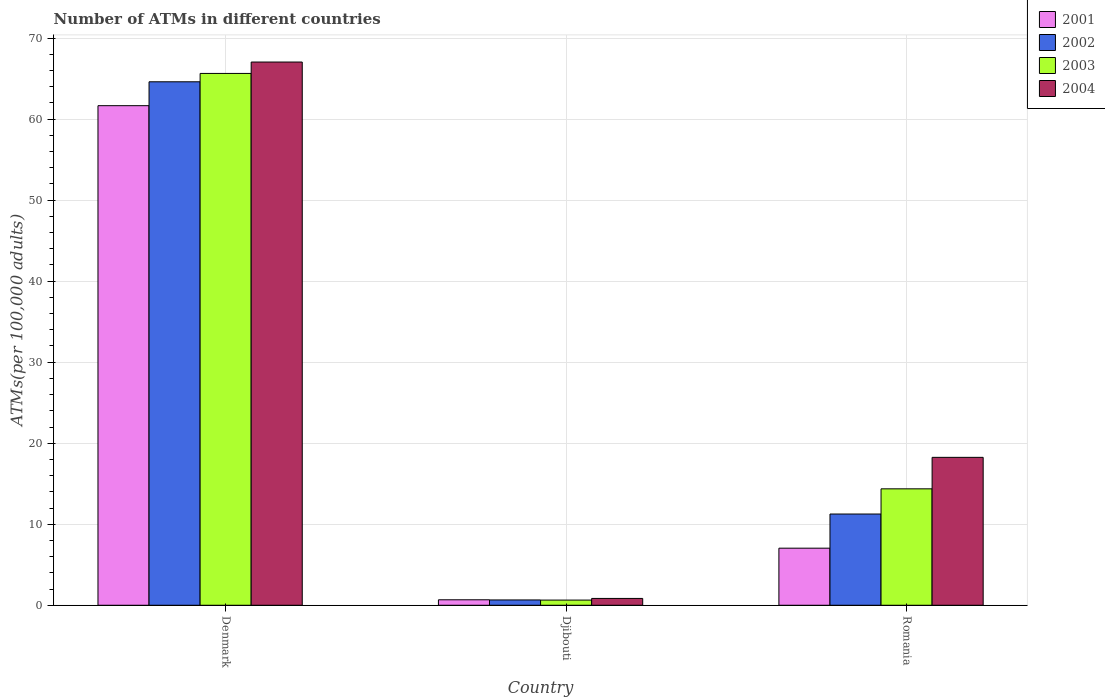Are the number of bars per tick equal to the number of legend labels?
Make the answer very short. Yes. How many bars are there on the 1st tick from the left?
Make the answer very short. 4. What is the label of the 3rd group of bars from the left?
Your answer should be compact. Romania. In how many cases, is the number of bars for a given country not equal to the number of legend labels?
Provide a short and direct response. 0. What is the number of ATMs in 2003 in Denmark?
Your response must be concise. 65.64. Across all countries, what is the maximum number of ATMs in 2004?
Your answer should be very brief. 67.04. Across all countries, what is the minimum number of ATMs in 2002?
Your response must be concise. 0.66. In which country was the number of ATMs in 2001 maximum?
Provide a succinct answer. Denmark. In which country was the number of ATMs in 2003 minimum?
Give a very brief answer. Djibouti. What is the total number of ATMs in 2003 in the graph?
Provide a short and direct response. 80.65. What is the difference between the number of ATMs in 2001 in Djibouti and that in Romania?
Provide a short and direct response. -6.37. What is the difference between the number of ATMs in 2004 in Djibouti and the number of ATMs in 2002 in Denmark?
Ensure brevity in your answer.  -63.76. What is the average number of ATMs in 2001 per country?
Provide a short and direct response. 23.13. What is the difference between the number of ATMs of/in 2004 and number of ATMs of/in 2003 in Romania?
Provide a succinct answer. 3.89. What is the ratio of the number of ATMs in 2001 in Denmark to that in Djibouti?
Your response must be concise. 91.18. Is the number of ATMs in 2002 in Denmark less than that in Romania?
Offer a very short reply. No. Is the difference between the number of ATMs in 2004 in Djibouti and Romania greater than the difference between the number of ATMs in 2003 in Djibouti and Romania?
Keep it short and to the point. No. What is the difference between the highest and the second highest number of ATMs in 2001?
Offer a very short reply. -60.98. What is the difference between the highest and the lowest number of ATMs in 2003?
Give a very brief answer. 65. Are all the bars in the graph horizontal?
Your answer should be very brief. No. What is the difference between two consecutive major ticks on the Y-axis?
Ensure brevity in your answer.  10. Does the graph contain any zero values?
Offer a terse response. No. Where does the legend appear in the graph?
Offer a very short reply. Top right. What is the title of the graph?
Your answer should be very brief. Number of ATMs in different countries. What is the label or title of the X-axis?
Your response must be concise. Country. What is the label or title of the Y-axis?
Offer a very short reply. ATMs(per 100,0 adults). What is the ATMs(per 100,000 adults) of 2001 in Denmark?
Your answer should be very brief. 61.66. What is the ATMs(per 100,000 adults) in 2002 in Denmark?
Provide a succinct answer. 64.61. What is the ATMs(per 100,000 adults) of 2003 in Denmark?
Give a very brief answer. 65.64. What is the ATMs(per 100,000 adults) of 2004 in Denmark?
Provide a succinct answer. 67.04. What is the ATMs(per 100,000 adults) of 2001 in Djibouti?
Keep it short and to the point. 0.68. What is the ATMs(per 100,000 adults) of 2002 in Djibouti?
Offer a terse response. 0.66. What is the ATMs(per 100,000 adults) of 2003 in Djibouti?
Your answer should be compact. 0.64. What is the ATMs(per 100,000 adults) in 2004 in Djibouti?
Offer a very short reply. 0.84. What is the ATMs(per 100,000 adults) of 2001 in Romania?
Your response must be concise. 7.04. What is the ATMs(per 100,000 adults) of 2002 in Romania?
Keep it short and to the point. 11.26. What is the ATMs(per 100,000 adults) in 2003 in Romania?
Offer a terse response. 14.37. What is the ATMs(per 100,000 adults) in 2004 in Romania?
Make the answer very short. 18.26. Across all countries, what is the maximum ATMs(per 100,000 adults) of 2001?
Your response must be concise. 61.66. Across all countries, what is the maximum ATMs(per 100,000 adults) in 2002?
Offer a terse response. 64.61. Across all countries, what is the maximum ATMs(per 100,000 adults) in 2003?
Your answer should be very brief. 65.64. Across all countries, what is the maximum ATMs(per 100,000 adults) of 2004?
Your response must be concise. 67.04. Across all countries, what is the minimum ATMs(per 100,000 adults) of 2001?
Offer a terse response. 0.68. Across all countries, what is the minimum ATMs(per 100,000 adults) in 2002?
Ensure brevity in your answer.  0.66. Across all countries, what is the minimum ATMs(per 100,000 adults) in 2003?
Your answer should be compact. 0.64. Across all countries, what is the minimum ATMs(per 100,000 adults) in 2004?
Your response must be concise. 0.84. What is the total ATMs(per 100,000 adults) in 2001 in the graph?
Ensure brevity in your answer.  69.38. What is the total ATMs(per 100,000 adults) of 2002 in the graph?
Offer a very short reply. 76.52. What is the total ATMs(per 100,000 adults) of 2003 in the graph?
Offer a very short reply. 80.65. What is the total ATMs(per 100,000 adults) in 2004 in the graph?
Ensure brevity in your answer.  86.14. What is the difference between the ATMs(per 100,000 adults) in 2001 in Denmark and that in Djibouti?
Offer a terse response. 60.98. What is the difference between the ATMs(per 100,000 adults) of 2002 in Denmark and that in Djibouti?
Ensure brevity in your answer.  63.95. What is the difference between the ATMs(per 100,000 adults) of 2003 in Denmark and that in Djibouti?
Provide a short and direct response. 65. What is the difference between the ATMs(per 100,000 adults) in 2004 in Denmark and that in Djibouti?
Provide a short and direct response. 66.2. What is the difference between the ATMs(per 100,000 adults) of 2001 in Denmark and that in Romania?
Offer a terse response. 54.61. What is the difference between the ATMs(per 100,000 adults) of 2002 in Denmark and that in Romania?
Make the answer very short. 53.35. What is the difference between the ATMs(per 100,000 adults) in 2003 in Denmark and that in Romania?
Make the answer very short. 51.27. What is the difference between the ATMs(per 100,000 adults) in 2004 in Denmark and that in Romania?
Ensure brevity in your answer.  48.79. What is the difference between the ATMs(per 100,000 adults) in 2001 in Djibouti and that in Romania?
Your response must be concise. -6.37. What is the difference between the ATMs(per 100,000 adults) in 2002 in Djibouti and that in Romania?
Make the answer very short. -10.6. What is the difference between the ATMs(per 100,000 adults) in 2003 in Djibouti and that in Romania?
Your answer should be very brief. -13.73. What is the difference between the ATMs(per 100,000 adults) in 2004 in Djibouti and that in Romania?
Keep it short and to the point. -17.41. What is the difference between the ATMs(per 100,000 adults) of 2001 in Denmark and the ATMs(per 100,000 adults) of 2002 in Djibouti?
Your answer should be compact. 61. What is the difference between the ATMs(per 100,000 adults) of 2001 in Denmark and the ATMs(per 100,000 adults) of 2003 in Djibouti?
Your answer should be compact. 61.02. What is the difference between the ATMs(per 100,000 adults) of 2001 in Denmark and the ATMs(per 100,000 adults) of 2004 in Djibouti?
Give a very brief answer. 60.81. What is the difference between the ATMs(per 100,000 adults) of 2002 in Denmark and the ATMs(per 100,000 adults) of 2003 in Djibouti?
Provide a succinct answer. 63.97. What is the difference between the ATMs(per 100,000 adults) of 2002 in Denmark and the ATMs(per 100,000 adults) of 2004 in Djibouti?
Make the answer very short. 63.76. What is the difference between the ATMs(per 100,000 adults) in 2003 in Denmark and the ATMs(per 100,000 adults) in 2004 in Djibouti?
Make the answer very short. 64.79. What is the difference between the ATMs(per 100,000 adults) in 2001 in Denmark and the ATMs(per 100,000 adults) in 2002 in Romania?
Make the answer very short. 50.4. What is the difference between the ATMs(per 100,000 adults) in 2001 in Denmark and the ATMs(per 100,000 adults) in 2003 in Romania?
Give a very brief answer. 47.29. What is the difference between the ATMs(per 100,000 adults) of 2001 in Denmark and the ATMs(per 100,000 adults) of 2004 in Romania?
Provide a succinct answer. 43.4. What is the difference between the ATMs(per 100,000 adults) in 2002 in Denmark and the ATMs(per 100,000 adults) in 2003 in Romania?
Offer a terse response. 50.24. What is the difference between the ATMs(per 100,000 adults) in 2002 in Denmark and the ATMs(per 100,000 adults) in 2004 in Romania?
Offer a terse response. 46.35. What is the difference between the ATMs(per 100,000 adults) in 2003 in Denmark and the ATMs(per 100,000 adults) in 2004 in Romania?
Offer a terse response. 47.38. What is the difference between the ATMs(per 100,000 adults) of 2001 in Djibouti and the ATMs(per 100,000 adults) of 2002 in Romania?
Your answer should be very brief. -10.58. What is the difference between the ATMs(per 100,000 adults) of 2001 in Djibouti and the ATMs(per 100,000 adults) of 2003 in Romania?
Ensure brevity in your answer.  -13.69. What is the difference between the ATMs(per 100,000 adults) in 2001 in Djibouti and the ATMs(per 100,000 adults) in 2004 in Romania?
Keep it short and to the point. -17.58. What is the difference between the ATMs(per 100,000 adults) of 2002 in Djibouti and the ATMs(per 100,000 adults) of 2003 in Romania?
Offer a terse response. -13.71. What is the difference between the ATMs(per 100,000 adults) of 2002 in Djibouti and the ATMs(per 100,000 adults) of 2004 in Romania?
Your answer should be compact. -17.6. What is the difference between the ATMs(per 100,000 adults) in 2003 in Djibouti and the ATMs(per 100,000 adults) in 2004 in Romania?
Provide a short and direct response. -17.62. What is the average ATMs(per 100,000 adults) in 2001 per country?
Your response must be concise. 23.13. What is the average ATMs(per 100,000 adults) in 2002 per country?
Your response must be concise. 25.51. What is the average ATMs(per 100,000 adults) of 2003 per country?
Provide a short and direct response. 26.88. What is the average ATMs(per 100,000 adults) in 2004 per country?
Offer a very short reply. 28.71. What is the difference between the ATMs(per 100,000 adults) in 2001 and ATMs(per 100,000 adults) in 2002 in Denmark?
Provide a succinct answer. -2.95. What is the difference between the ATMs(per 100,000 adults) of 2001 and ATMs(per 100,000 adults) of 2003 in Denmark?
Make the answer very short. -3.98. What is the difference between the ATMs(per 100,000 adults) of 2001 and ATMs(per 100,000 adults) of 2004 in Denmark?
Keep it short and to the point. -5.39. What is the difference between the ATMs(per 100,000 adults) in 2002 and ATMs(per 100,000 adults) in 2003 in Denmark?
Give a very brief answer. -1.03. What is the difference between the ATMs(per 100,000 adults) in 2002 and ATMs(per 100,000 adults) in 2004 in Denmark?
Your answer should be very brief. -2.44. What is the difference between the ATMs(per 100,000 adults) in 2003 and ATMs(per 100,000 adults) in 2004 in Denmark?
Your answer should be compact. -1.41. What is the difference between the ATMs(per 100,000 adults) in 2001 and ATMs(per 100,000 adults) in 2002 in Djibouti?
Make the answer very short. 0.02. What is the difference between the ATMs(per 100,000 adults) in 2001 and ATMs(per 100,000 adults) in 2003 in Djibouti?
Make the answer very short. 0.04. What is the difference between the ATMs(per 100,000 adults) of 2001 and ATMs(per 100,000 adults) of 2004 in Djibouti?
Your response must be concise. -0.17. What is the difference between the ATMs(per 100,000 adults) in 2002 and ATMs(per 100,000 adults) in 2003 in Djibouti?
Your answer should be compact. 0.02. What is the difference between the ATMs(per 100,000 adults) of 2002 and ATMs(per 100,000 adults) of 2004 in Djibouti?
Make the answer very short. -0.19. What is the difference between the ATMs(per 100,000 adults) of 2003 and ATMs(per 100,000 adults) of 2004 in Djibouti?
Make the answer very short. -0.21. What is the difference between the ATMs(per 100,000 adults) of 2001 and ATMs(per 100,000 adults) of 2002 in Romania?
Give a very brief answer. -4.21. What is the difference between the ATMs(per 100,000 adults) in 2001 and ATMs(per 100,000 adults) in 2003 in Romania?
Your answer should be very brief. -7.32. What is the difference between the ATMs(per 100,000 adults) in 2001 and ATMs(per 100,000 adults) in 2004 in Romania?
Your answer should be compact. -11.21. What is the difference between the ATMs(per 100,000 adults) in 2002 and ATMs(per 100,000 adults) in 2003 in Romania?
Your response must be concise. -3.11. What is the difference between the ATMs(per 100,000 adults) of 2002 and ATMs(per 100,000 adults) of 2004 in Romania?
Ensure brevity in your answer.  -7. What is the difference between the ATMs(per 100,000 adults) of 2003 and ATMs(per 100,000 adults) of 2004 in Romania?
Offer a terse response. -3.89. What is the ratio of the ATMs(per 100,000 adults) in 2001 in Denmark to that in Djibouti?
Your response must be concise. 91.18. What is the ratio of the ATMs(per 100,000 adults) in 2002 in Denmark to that in Djibouti?
Give a very brief answer. 98.45. What is the ratio of the ATMs(per 100,000 adults) in 2003 in Denmark to that in Djibouti?
Offer a very short reply. 102.88. What is the ratio of the ATMs(per 100,000 adults) in 2004 in Denmark to that in Djibouti?
Make the answer very short. 79.46. What is the ratio of the ATMs(per 100,000 adults) of 2001 in Denmark to that in Romania?
Keep it short and to the point. 8.75. What is the ratio of the ATMs(per 100,000 adults) in 2002 in Denmark to that in Romania?
Keep it short and to the point. 5.74. What is the ratio of the ATMs(per 100,000 adults) in 2003 in Denmark to that in Romania?
Keep it short and to the point. 4.57. What is the ratio of the ATMs(per 100,000 adults) of 2004 in Denmark to that in Romania?
Keep it short and to the point. 3.67. What is the ratio of the ATMs(per 100,000 adults) in 2001 in Djibouti to that in Romania?
Provide a short and direct response. 0.1. What is the ratio of the ATMs(per 100,000 adults) in 2002 in Djibouti to that in Romania?
Keep it short and to the point. 0.06. What is the ratio of the ATMs(per 100,000 adults) of 2003 in Djibouti to that in Romania?
Offer a very short reply. 0.04. What is the ratio of the ATMs(per 100,000 adults) in 2004 in Djibouti to that in Romania?
Your answer should be compact. 0.05. What is the difference between the highest and the second highest ATMs(per 100,000 adults) of 2001?
Your response must be concise. 54.61. What is the difference between the highest and the second highest ATMs(per 100,000 adults) of 2002?
Your answer should be very brief. 53.35. What is the difference between the highest and the second highest ATMs(per 100,000 adults) in 2003?
Your response must be concise. 51.27. What is the difference between the highest and the second highest ATMs(per 100,000 adults) of 2004?
Give a very brief answer. 48.79. What is the difference between the highest and the lowest ATMs(per 100,000 adults) of 2001?
Provide a succinct answer. 60.98. What is the difference between the highest and the lowest ATMs(per 100,000 adults) in 2002?
Ensure brevity in your answer.  63.95. What is the difference between the highest and the lowest ATMs(per 100,000 adults) in 2003?
Keep it short and to the point. 65. What is the difference between the highest and the lowest ATMs(per 100,000 adults) in 2004?
Ensure brevity in your answer.  66.2. 